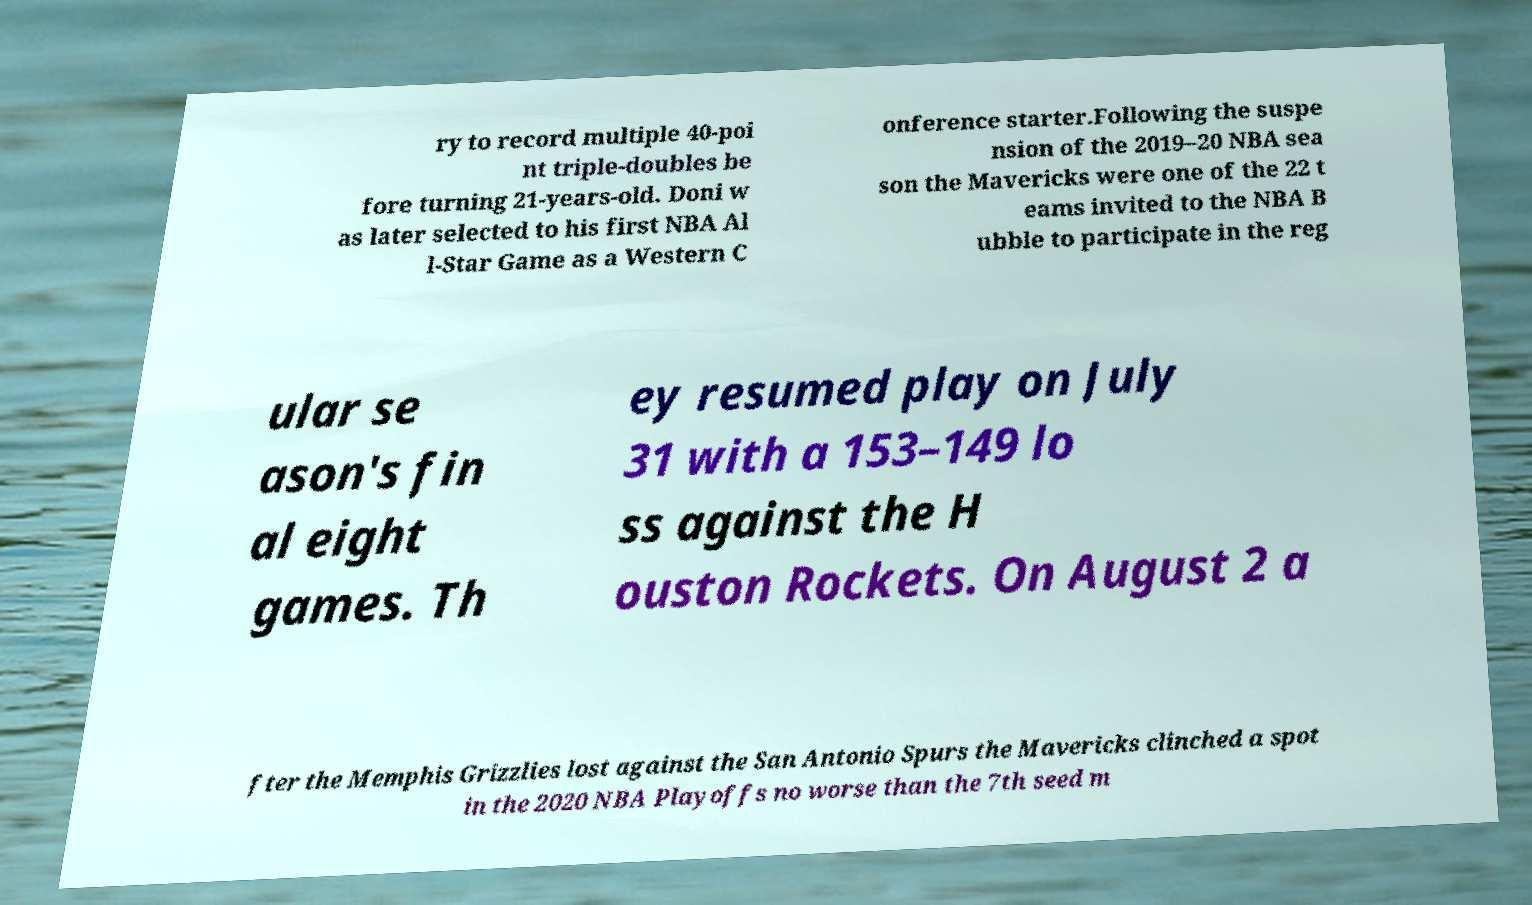Could you extract and type out the text from this image? ry to record multiple 40-poi nt triple-doubles be fore turning 21-years-old. Doni w as later selected to his first NBA Al l-Star Game as a Western C onference starter.Following the suspe nsion of the 2019–20 NBA sea son the Mavericks were one of the 22 t eams invited to the NBA B ubble to participate in the reg ular se ason's fin al eight games. Th ey resumed play on July 31 with a 153–149 lo ss against the H ouston Rockets. On August 2 a fter the Memphis Grizzlies lost against the San Antonio Spurs the Mavericks clinched a spot in the 2020 NBA Playoffs no worse than the 7th seed m 